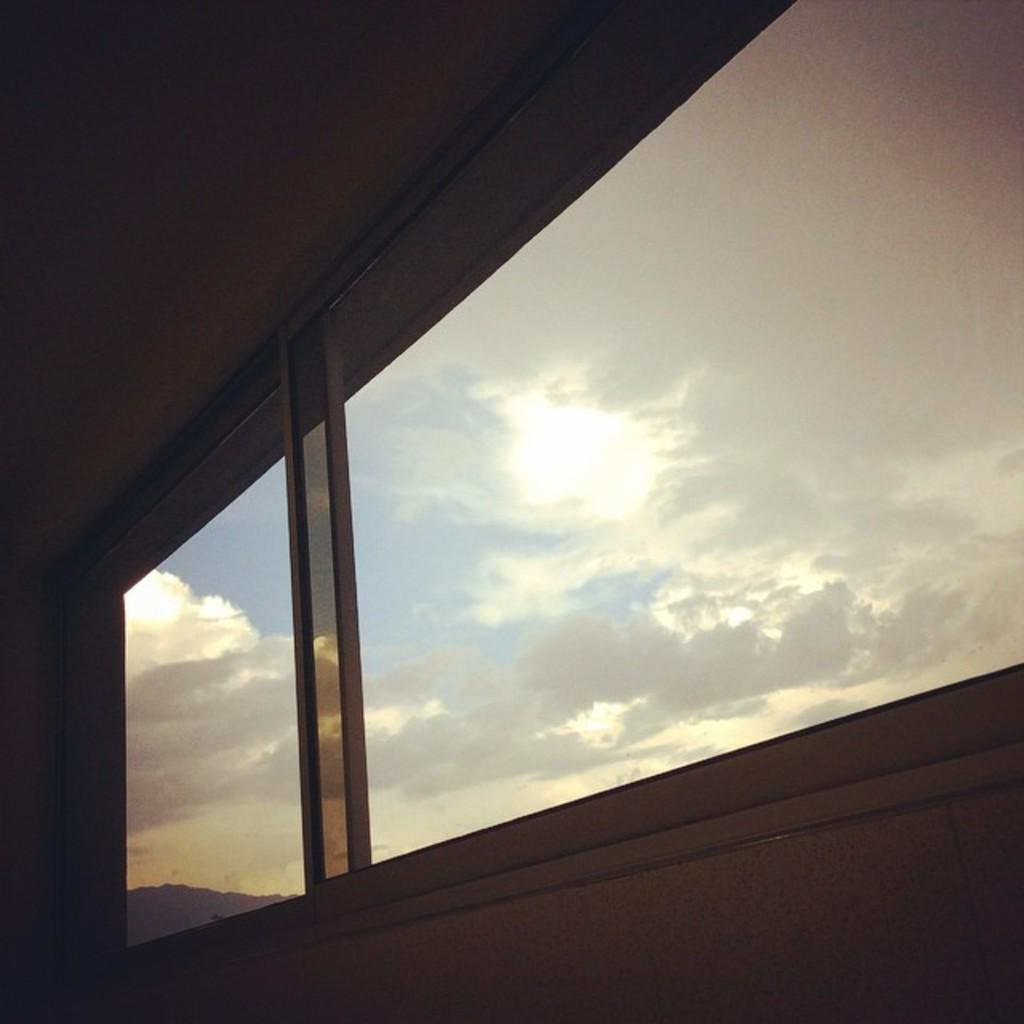What type of space is depicted in the image? There is a room in the image. What feature can be seen in the room? There is a window in the room. How would you describe the weather outside the window? The sky outside the window is pleasant, with white clouds visible. Is the sun directly visible in the image? No, the sun is hidden under the clouds. What type of quilt is draped over the window in the image? There is no quilt present in the image; it only features a window with a pleasant sky outside. 